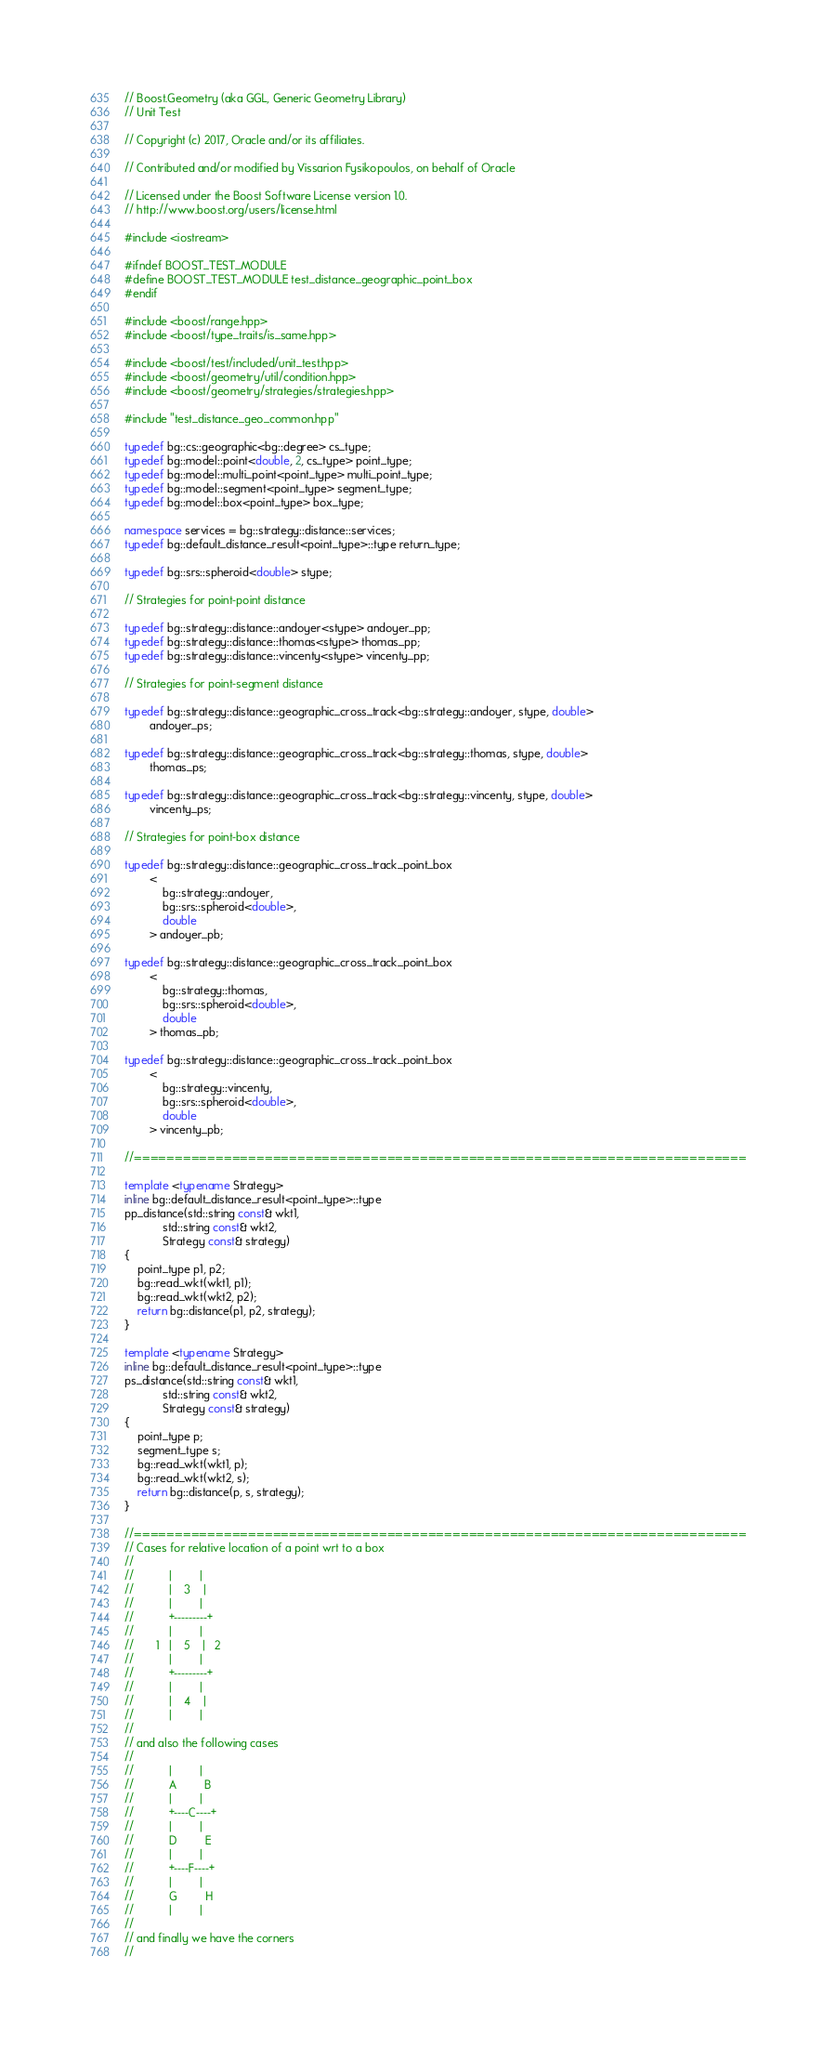<code> <loc_0><loc_0><loc_500><loc_500><_C++_>// Boost.Geometry (aka GGL, Generic Geometry Library)
// Unit Test

// Copyright (c) 2017, Oracle and/or its affiliates.

// Contributed and/or modified by Vissarion Fysikopoulos, on behalf of Oracle

// Licensed under the Boost Software License version 1.0.
// http://www.boost.org/users/license.html

#include <iostream>

#ifndef BOOST_TEST_MODULE
#define BOOST_TEST_MODULE test_distance_geographic_point_box
#endif

#include <boost/range.hpp>
#include <boost/type_traits/is_same.hpp>

#include <boost/test/included/unit_test.hpp>
#include <boost/geometry/util/condition.hpp>
#include <boost/geometry/strategies/strategies.hpp>

#include "test_distance_geo_common.hpp"

typedef bg::cs::geographic<bg::degree> cs_type;
typedef bg::model::point<double, 2, cs_type> point_type;
typedef bg::model::multi_point<point_type> multi_point_type;
typedef bg::model::segment<point_type> segment_type;
typedef bg::model::box<point_type> box_type;

namespace services = bg::strategy::distance::services;
typedef bg::default_distance_result<point_type>::type return_type;

typedef bg::srs::spheroid<double> stype;

// Strategies for point-point distance

typedef bg::strategy::distance::andoyer<stype> andoyer_pp;
typedef bg::strategy::distance::thomas<stype> thomas_pp;
typedef bg::strategy::distance::vincenty<stype> vincenty_pp;

// Strategies for point-segment distance

typedef bg::strategy::distance::geographic_cross_track<bg::strategy::andoyer, stype, double>
        andoyer_ps;

typedef bg::strategy::distance::geographic_cross_track<bg::strategy::thomas, stype, double>
        thomas_ps;

typedef bg::strategy::distance::geographic_cross_track<bg::strategy::vincenty, stype, double>
        vincenty_ps;

// Strategies for point-box distance

typedef bg::strategy::distance::geographic_cross_track_point_box
        <
            bg::strategy::andoyer,
            bg::srs::spheroid<double>,
            double
        > andoyer_pb;

typedef bg::strategy::distance::geographic_cross_track_point_box
        <
            bg::strategy::thomas,
            bg::srs::spheroid<double>,
            double
        > thomas_pb;

typedef bg::strategy::distance::geographic_cross_track_point_box
        <
            bg::strategy::vincenty,
            bg::srs::spheroid<double>,
            double
        > vincenty_pb;

//===========================================================================

template <typename Strategy>
inline bg::default_distance_result<point_type>::type
pp_distance(std::string const& wkt1,
            std::string const& wkt2,
            Strategy const& strategy)
{
    point_type p1, p2;
    bg::read_wkt(wkt1, p1);
    bg::read_wkt(wkt2, p2);
    return bg::distance(p1, p2, strategy);
}

template <typename Strategy>
inline bg::default_distance_result<point_type>::type
ps_distance(std::string const& wkt1,
            std::string const& wkt2,
            Strategy const& strategy)
{
    point_type p;
    segment_type s;
    bg::read_wkt(wkt1, p);
    bg::read_wkt(wkt2, s);
    return bg::distance(p, s, strategy);
}

//===========================================================================
// Cases for relative location of a point wrt to a box
//
//           |         |
//           |    3    |
//           |         |
//           +---------+
//           |         |
//       1   |    5    |   2
//           |         |
//           +---------+
//           |         |
//           |    4    |
//           |         |
//
// and also the following cases
//
//           |         |
//           A         B
//           |         |
//           +----C----+
//           |         |
//           D         E
//           |         |
//           +----F----+
//           |         |
//           G         H
//           |         |
//
// and finally we have the corners
//</code> 